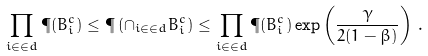<formula> <loc_0><loc_0><loc_500><loc_500>\prod _ { i \in \in d } \P ( B _ { i } ^ { c } ) \leq \P \left ( \cap _ { i \in \in d } B _ { i } ^ { c } \right ) \leq \prod _ { i \in \in d } \P ( B _ { i } ^ { c } ) \exp \left ( \frac { \gamma } { 2 ( 1 - \beta ) } \right ) \, .</formula> 